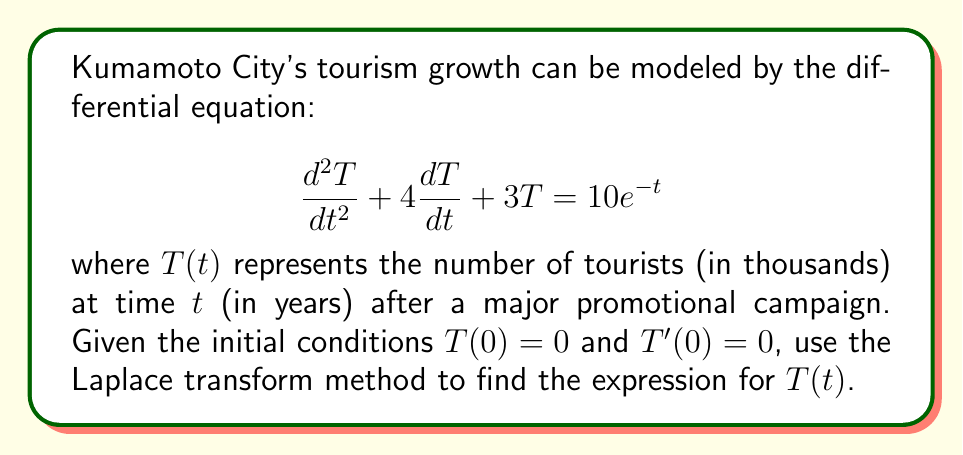Can you answer this question? Let's solve this problem step by step using the Laplace transform method:

1) Take the Laplace transform of both sides of the equation:
   $$\mathcal{L}\{T''(t) + 4T'(t) + 3T(t)\} = \mathcal{L}\{10e^{-t}\}$$

2) Using Laplace transform properties:
   $$[s^2\mathcal{L}\{T(t)\} - sT(0) - T'(0)] + 4[s\mathcal{L}\{T(t)\} - T(0)] + 3\mathcal{L}\{T(t)\} = \frac{10}{s+1}$$

3) Substitute the initial conditions $T(0) = 0$ and $T'(0) = 0$:
   $$s^2\mathcal{L}\{T(t)\} + 4s\mathcal{L}\{T(t)\} + 3\mathcal{L}\{T(t)\} = \frac{10}{s+1}$$

4) Factor out $\mathcal{L}\{T(t)\}$:
   $$\mathcal{L}\{T(t)\}(s^2 + 4s + 3) = \frac{10}{s+1}$$

5) Solve for $\mathcal{L}\{T(t)\}$:
   $$\mathcal{L}\{T(t)\} = \frac{10}{(s+1)(s^2 + 4s + 3)}$$

6) Factor the denominator:
   $$\mathcal{L}\{T(t)\} = \frac{10}{(s+1)(s+1)(s+3)}$$

7) Use partial fraction decomposition:
   $$\mathcal{L}\{T(t)\} = \frac{A}{s+1} + \frac{B}{(s+1)^2} + \frac{C}{s+3}$$

8) Solve for A, B, and C:
   $$A = 5, B = -5, C = -\frac{5}{2}$$

9) Rewrite the equation:
   $$\mathcal{L}\{T(t)\} = \frac{5}{s+1} - \frac{5}{(s+1)^2} - \frac{5/2}{s+3}$$

10) Take the inverse Laplace transform:
    $$T(t) = 5e^{-t} - 5te^{-t} - \frac{5}{2}e^{-3t}$$

This is the final expression for $T(t)$, representing the number of tourists in thousands as a function of time in years.
Answer: $T(t) = 5e^{-t} - 5te^{-t} - \frac{5}{2}e^{-3t}$ 